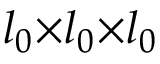Convert formula to latex. <formula><loc_0><loc_0><loc_500><loc_500>l _ { 0 } { \times } l _ { 0 } { \times } l _ { 0 }</formula> 